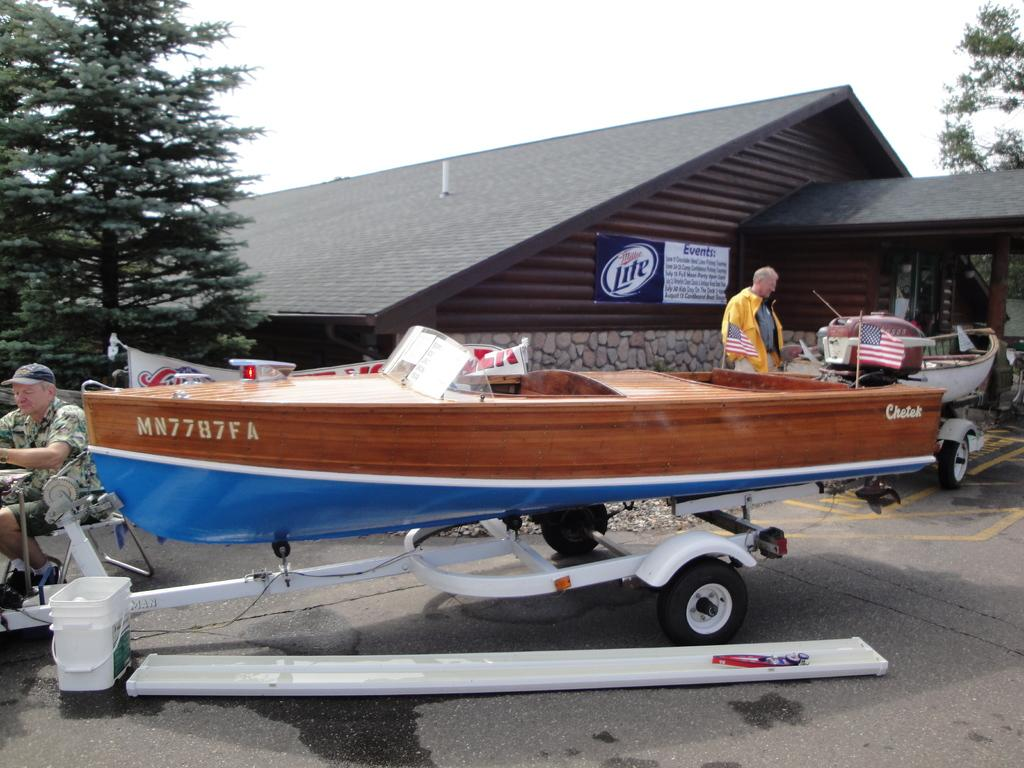<image>
Write a terse but informative summary of the picture. Blue and woodgrain speed boat named Chetek sitting in front of a structure with a Miller Lite sign. 